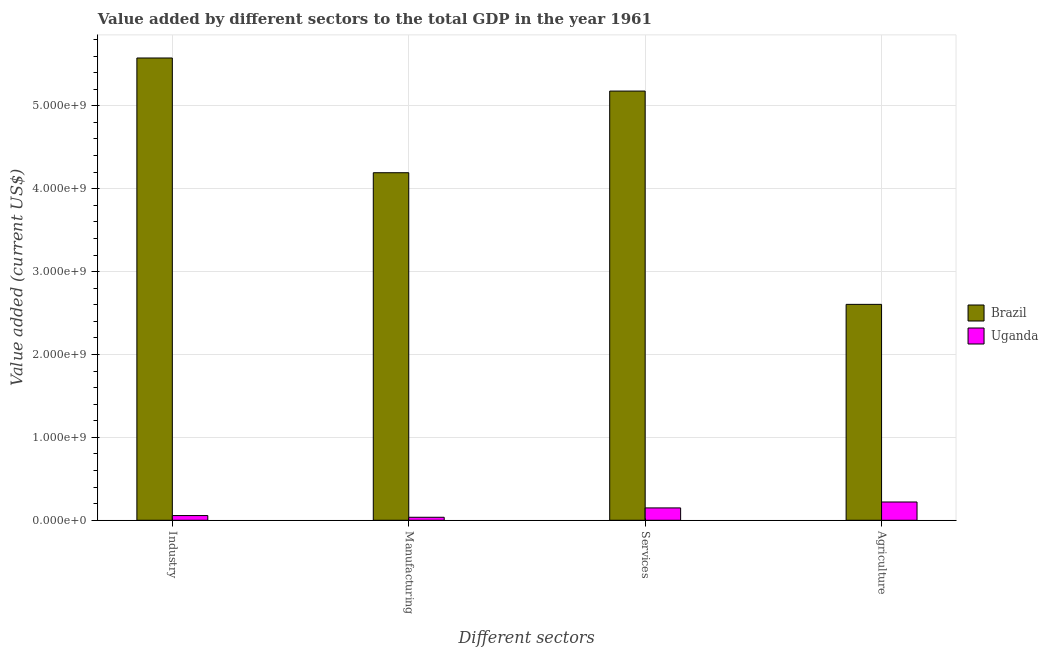How many different coloured bars are there?
Your answer should be compact. 2. Are the number of bars per tick equal to the number of legend labels?
Give a very brief answer. Yes. Are the number of bars on each tick of the X-axis equal?
Your response must be concise. Yes. What is the label of the 2nd group of bars from the left?
Offer a very short reply. Manufacturing. What is the value added by services sector in Uganda?
Your answer should be compact. 1.49e+08. Across all countries, what is the maximum value added by industrial sector?
Ensure brevity in your answer.  5.58e+09. Across all countries, what is the minimum value added by agricultural sector?
Your response must be concise. 2.20e+08. In which country was the value added by industrial sector maximum?
Make the answer very short. Brazil. In which country was the value added by industrial sector minimum?
Ensure brevity in your answer.  Uganda. What is the total value added by agricultural sector in the graph?
Offer a very short reply. 2.83e+09. What is the difference between the value added by industrial sector in Uganda and that in Brazil?
Make the answer very short. -5.52e+09. What is the difference between the value added by agricultural sector in Uganda and the value added by manufacturing sector in Brazil?
Give a very brief answer. -3.97e+09. What is the average value added by services sector per country?
Keep it short and to the point. 2.66e+09. What is the difference between the value added by services sector and value added by manufacturing sector in Brazil?
Provide a short and direct response. 9.85e+08. In how many countries, is the value added by agricultural sector greater than 2800000000 US$?
Keep it short and to the point. 0. What is the ratio of the value added by manufacturing sector in Uganda to that in Brazil?
Provide a short and direct response. 0.01. What is the difference between the highest and the second highest value added by services sector?
Make the answer very short. 5.03e+09. What is the difference between the highest and the lowest value added by manufacturing sector?
Offer a terse response. 4.16e+09. In how many countries, is the value added by agricultural sector greater than the average value added by agricultural sector taken over all countries?
Your answer should be very brief. 1. What does the 2nd bar from the left in Manufacturing represents?
Your answer should be very brief. Uganda. What does the 1st bar from the right in Services represents?
Provide a succinct answer. Uganda. Is it the case that in every country, the sum of the value added by industrial sector and value added by manufacturing sector is greater than the value added by services sector?
Your answer should be very brief. No. How many bars are there?
Offer a very short reply. 8. How many countries are there in the graph?
Give a very brief answer. 2. What is the difference between two consecutive major ticks on the Y-axis?
Make the answer very short. 1.00e+09. Does the graph contain grids?
Your answer should be very brief. Yes. What is the title of the graph?
Offer a very short reply. Value added by different sectors to the total GDP in the year 1961. What is the label or title of the X-axis?
Your response must be concise. Different sectors. What is the label or title of the Y-axis?
Offer a terse response. Value added (current US$). What is the Value added (current US$) of Brazil in Industry?
Keep it short and to the point. 5.58e+09. What is the Value added (current US$) of Uganda in Industry?
Provide a succinct answer. 5.67e+07. What is the Value added (current US$) in Brazil in Manufacturing?
Your answer should be compact. 4.19e+09. What is the Value added (current US$) in Uganda in Manufacturing?
Offer a very short reply. 3.60e+07. What is the Value added (current US$) in Brazil in Services?
Your answer should be compact. 5.18e+09. What is the Value added (current US$) of Uganda in Services?
Provide a succinct answer. 1.49e+08. What is the Value added (current US$) in Brazil in Agriculture?
Ensure brevity in your answer.  2.60e+09. What is the Value added (current US$) of Uganda in Agriculture?
Your answer should be very brief. 2.20e+08. Across all Different sectors, what is the maximum Value added (current US$) of Brazil?
Provide a succinct answer. 5.58e+09. Across all Different sectors, what is the maximum Value added (current US$) of Uganda?
Your response must be concise. 2.20e+08. Across all Different sectors, what is the minimum Value added (current US$) of Brazil?
Provide a succinct answer. 2.60e+09. Across all Different sectors, what is the minimum Value added (current US$) in Uganda?
Ensure brevity in your answer.  3.60e+07. What is the total Value added (current US$) in Brazil in the graph?
Ensure brevity in your answer.  1.76e+1. What is the total Value added (current US$) in Uganda in the graph?
Your answer should be compact. 4.62e+08. What is the difference between the Value added (current US$) of Brazil in Industry and that in Manufacturing?
Make the answer very short. 1.38e+09. What is the difference between the Value added (current US$) in Uganda in Industry and that in Manufacturing?
Offer a terse response. 2.06e+07. What is the difference between the Value added (current US$) of Brazil in Industry and that in Services?
Offer a terse response. 3.99e+08. What is the difference between the Value added (current US$) in Uganda in Industry and that in Services?
Your answer should be compact. -9.23e+07. What is the difference between the Value added (current US$) of Brazil in Industry and that in Agriculture?
Provide a short and direct response. 2.97e+09. What is the difference between the Value added (current US$) of Uganda in Industry and that in Agriculture?
Offer a terse response. -1.64e+08. What is the difference between the Value added (current US$) of Brazil in Manufacturing and that in Services?
Keep it short and to the point. -9.85e+08. What is the difference between the Value added (current US$) of Uganda in Manufacturing and that in Services?
Your answer should be compact. -1.13e+08. What is the difference between the Value added (current US$) in Brazil in Manufacturing and that in Agriculture?
Provide a short and direct response. 1.59e+09. What is the difference between the Value added (current US$) of Uganda in Manufacturing and that in Agriculture?
Provide a short and direct response. -1.84e+08. What is the difference between the Value added (current US$) of Brazil in Services and that in Agriculture?
Keep it short and to the point. 2.57e+09. What is the difference between the Value added (current US$) of Uganda in Services and that in Agriculture?
Make the answer very short. -7.15e+07. What is the difference between the Value added (current US$) of Brazil in Industry and the Value added (current US$) of Uganda in Manufacturing?
Keep it short and to the point. 5.54e+09. What is the difference between the Value added (current US$) in Brazil in Industry and the Value added (current US$) in Uganda in Services?
Offer a terse response. 5.43e+09. What is the difference between the Value added (current US$) of Brazil in Industry and the Value added (current US$) of Uganda in Agriculture?
Make the answer very short. 5.36e+09. What is the difference between the Value added (current US$) in Brazil in Manufacturing and the Value added (current US$) in Uganda in Services?
Your answer should be compact. 4.04e+09. What is the difference between the Value added (current US$) of Brazil in Manufacturing and the Value added (current US$) of Uganda in Agriculture?
Offer a very short reply. 3.97e+09. What is the difference between the Value added (current US$) of Brazil in Services and the Value added (current US$) of Uganda in Agriculture?
Your response must be concise. 4.96e+09. What is the average Value added (current US$) of Brazil per Different sectors?
Provide a succinct answer. 4.39e+09. What is the average Value added (current US$) in Uganda per Different sectors?
Make the answer very short. 1.16e+08. What is the difference between the Value added (current US$) in Brazil and Value added (current US$) in Uganda in Industry?
Your answer should be compact. 5.52e+09. What is the difference between the Value added (current US$) of Brazil and Value added (current US$) of Uganda in Manufacturing?
Give a very brief answer. 4.16e+09. What is the difference between the Value added (current US$) of Brazil and Value added (current US$) of Uganda in Services?
Your answer should be compact. 5.03e+09. What is the difference between the Value added (current US$) in Brazil and Value added (current US$) in Uganda in Agriculture?
Your answer should be compact. 2.38e+09. What is the ratio of the Value added (current US$) in Brazil in Industry to that in Manufacturing?
Provide a succinct answer. 1.33. What is the ratio of the Value added (current US$) of Uganda in Industry to that in Manufacturing?
Make the answer very short. 1.57. What is the ratio of the Value added (current US$) of Brazil in Industry to that in Services?
Your answer should be very brief. 1.08. What is the ratio of the Value added (current US$) of Uganda in Industry to that in Services?
Offer a very short reply. 0.38. What is the ratio of the Value added (current US$) of Brazil in Industry to that in Agriculture?
Your answer should be compact. 2.14. What is the ratio of the Value added (current US$) of Uganda in Industry to that in Agriculture?
Offer a very short reply. 0.26. What is the ratio of the Value added (current US$) in Brazil in Manufacturing to that in Services?
Provide a succinct answer. 0.81. What is the ratio of the Value added (current US$) of Uganda in Manufacturing to that in Services?
Provide a short and direct response. 0.24. What is the ratio of the Value added (current US$) in Brazil in Manufacturing to that in Agriculture?
Ensure brevity in your answer.  1.61. What is the ratio of the Value added (current US$) of Uganda in Manufacturing to that in Agriculture?
Your answer should be compact. 0.16. What is the ratio of the Value added (current US$) of Brazil in Services to that in Agriculture?
Provide a succinct answer. 1.99. What is the ratio of the Value added (current US$) of Uganda in Services to that in Agriculture?
Ensure brevity in your answer.  0.68. What is the difference between the highest and the second highest Value added (current US$) of Brazil?
Your response must be concise. 3.99e+08. What is the difference between the highest and the second highest Value added (current US$) of Uganda?
Offer a terse response. 7.15e+07. What is the difference between the highest and the lowest Value added (current US$) of Brazil?
Your answer should be compact. 2.97e+09. What is the difference between the highest and the lowest Value added (current US$) of Uganda?
Ensure brevity in your answer.  1.84e+08. 